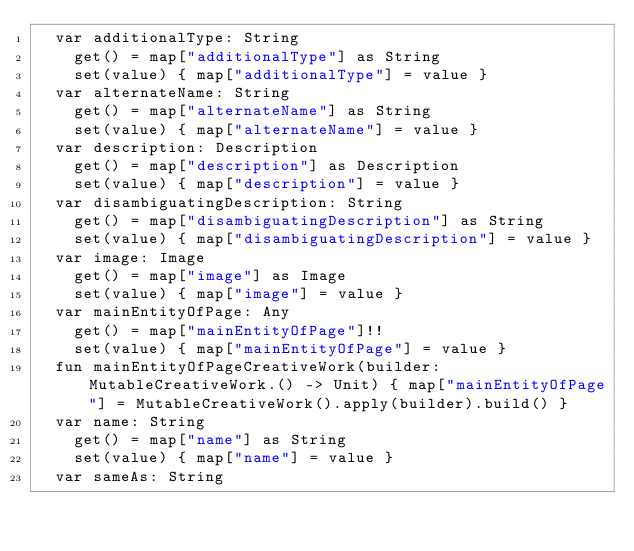<code> <loc_0><loc_0><loc_500><loc_500><_Kotlin_>  var additionalType: String
    get() = map["additionalType"] as String
    set(value) { map["additionalType"] = value }
  var alternateName: String
    get() = map["alternateName"] as String
    set(value) { map["alternateName"] = value }
  var description: Description
    get() = map["description"] as Description
    set(value) { map["description"] = value }
  var disambiguatingDescription: String
    get() = map["disambiguatingDescription"] as String
    set(value) { map["disambiguatingDescription"] = value }
  var image: Image
    get() = map["image"] as Image
    set(value) { map["image"] = value }
  var mainEntityOfPage: Any
    get() = map["mainEntityOfPage"]!!
    set(value) { map["mainEntityOfPage"] = value }
  fun mainEntityOfPageCreativeWork(builder: MutableCreativeWork.() -> Unit) { map["mainEntityOfPage"] = MutableCreativeWork().apply(builder).build() }
  var name: String
    get() = map["name"] as String
    set(value) { map["name"] = value }
  var sameAs: String</code> 